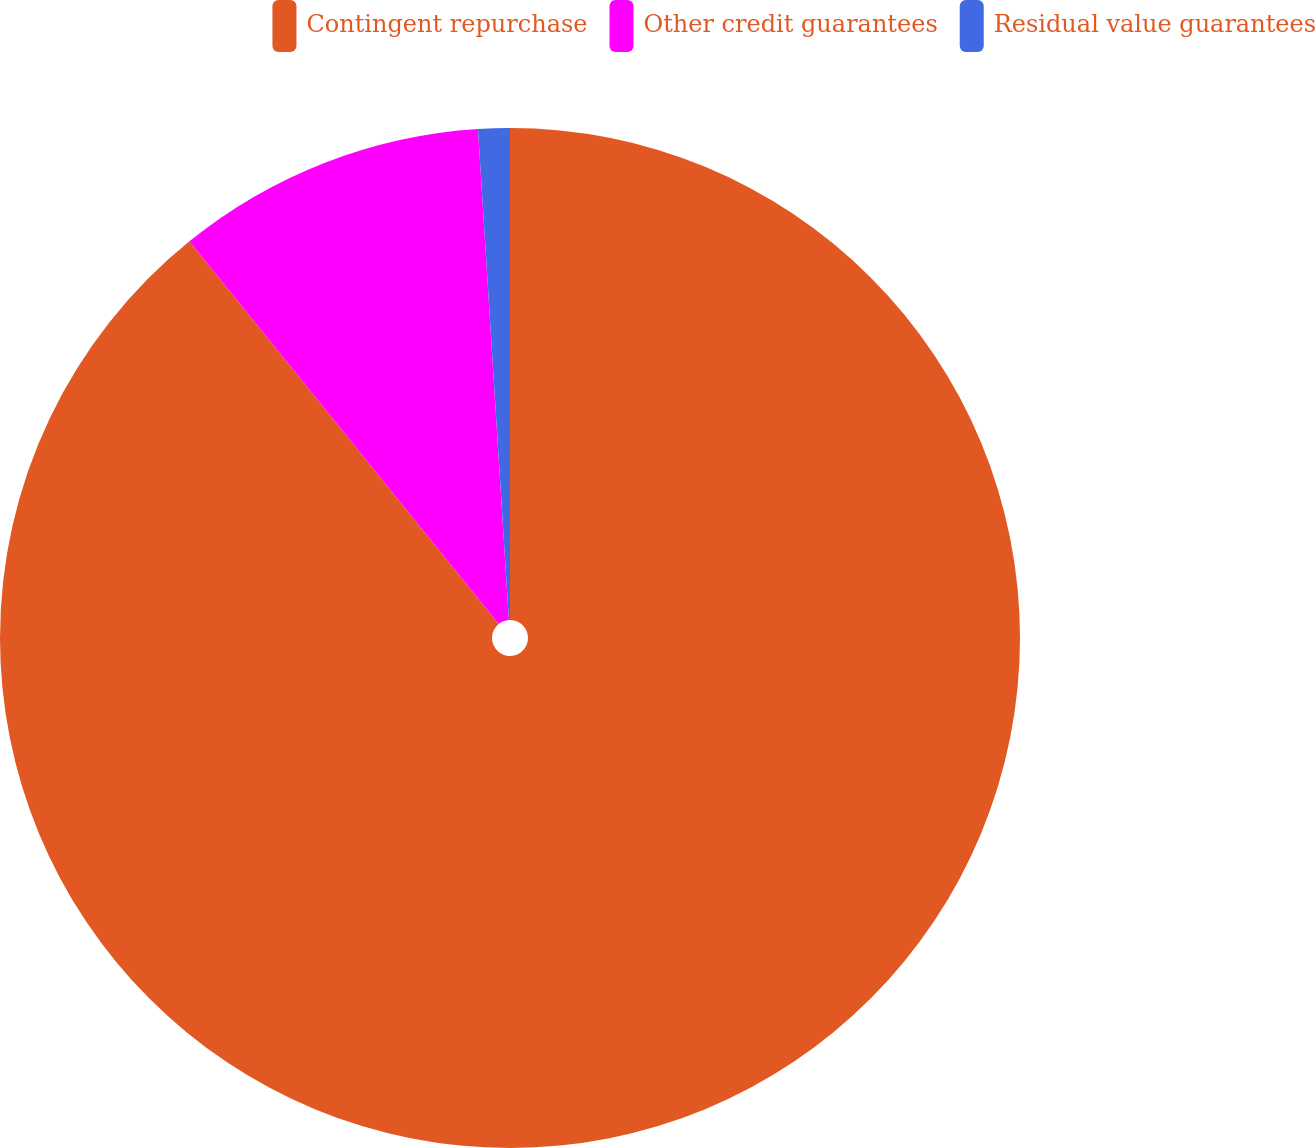Convert chart to OTSL. <chart><loc_0><loc_0><loc_500><loc_500><pie_chart><fcel>Contingent repurchase<fcel>Other credit guarantees<fcel>Residual value guarantees<nl><fcel>89.19%<fcel>9.82%<fcel>1.0%<nl></chart> 